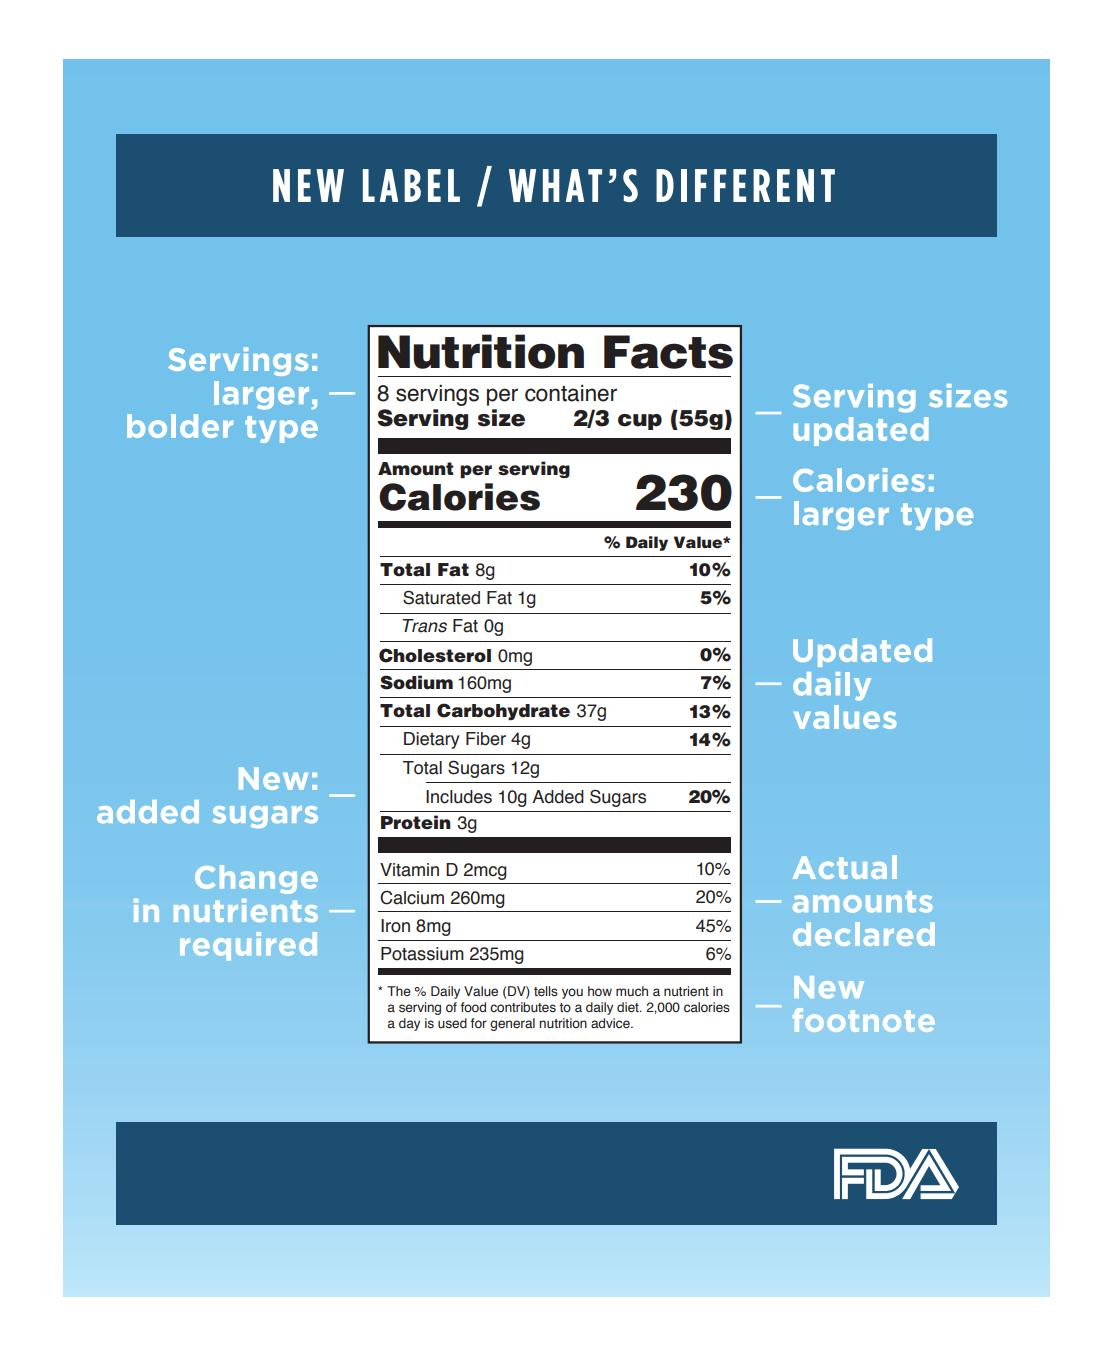Specify some key components in this picture. The new label emphasizes the number of servings in a larger, bolder type, which is indicated by the text 'Servings..'. The percentages of vitamins, calcium, iron, and other nutrients have been changed, and the actual amounts have been declared. Daily updated values for cholesterol, sodium, carbohydrates, and other nutrients have been changed. The new food nutrition label includes a new footnote. 